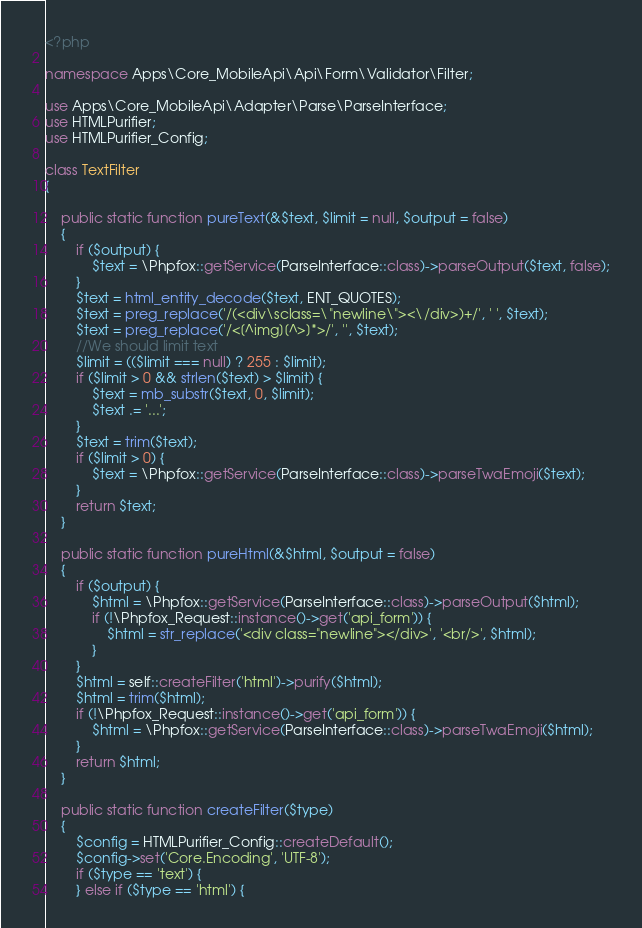<code> <loc_0><loc_0><loc_500><loc_500><_PHP_><?php

namespace Apps\Core_MobileApi\Api\Form\Validator\Filter;

use Apps\Core_MobileApi\Adapter\Parse\ParseInterface;
use HTMLPurifier;
use HTMLPurifier_Config;

class TextFilter
{

    public static function pureText(&$text, $limit = null, $output = false)
    {
        if ($output) {
            $text = \Phpfox::getService(ParseInterface::class)->parseOutput($text, false);
        }
        $text = html_entity_decode($text, ENT_QUOTES);
        $text = preg_replace('/(<div\sclass=\"newline\"><\/div>)+/', ' ', $text);
        $text = preg_replace('/<[^img][^>]*>/', '', $text);
        //We should limit text
        $limit = (($limit === null) ? 255 : $limit);
        if ($limit > 0 && strlen($text) > $limit) {
            $text = mb_substr($text, 0, $limit);
            $text .= '...';
        }
        $text = trim($text);
        if ($limit > 0) {
            $text = \Phpfox::getService(ParseInterface::class)->parseTwaEmoji($text);
        }
        return $text;
    }

    public static function pureHtml(&$html, $output = false)
    {
        if ($output) {
            $html = \Phpfox::getService(ParseInterface::class)->parseOutput($html);
            if (!\Phpfox_Request::instance()->get('api_form')) {
                $html = str_replace('<div class="newline"></div>', '<br/>', $html);
            }
        }
        $html = self::createFilter('html')->purify($html);
        $html = trim($html);
        if (!\Phpfox_Request::instance()->get('api_form')) {
            $html = \Phpfox::getService(ParseInterface::class)->parseTwaEmoji($html);
        }
        return $html;
    }

    public static function createFilter($type)
    {
        $config = HTMLPurifier_Config::createDefault();
        $config->set('Core.Encoding', 'UTF-8');
        if ($type == 'text') {
        } else if ($type == 'html') {</code> 